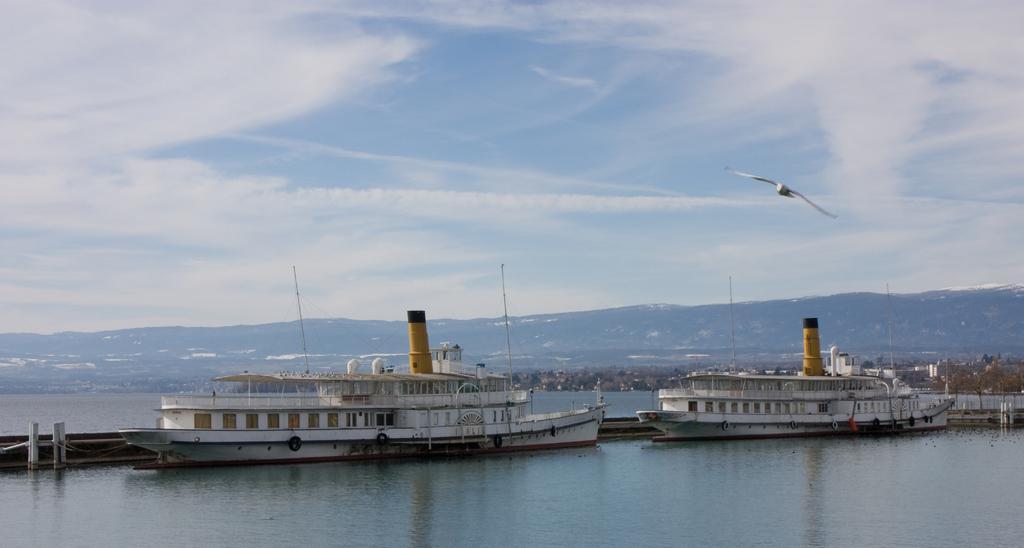In one or two sentences, can you explain what this image depicts? There are ships on the water. On the ships there are windows, railings, tires and many other items. Near to the ship there are poles. In the back there are hills and sky with clouds. Also there is a bird flying. And there are trees. 